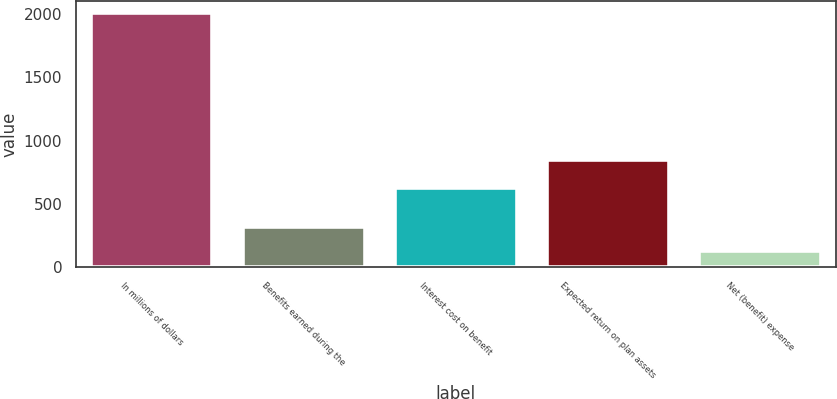Convert chart to OTSL. <chart><loc_0><loc_0><loc_500><loc_500><bar_chart><fcel>In millions of dollars<fcel>Benefits earned during the<fcel>Interest cost on benefit<fcel>Expected return on plan assets<fcel>Net (benefit) expense<nl><fcel>2006<fcel>318.5<fcel>630<fcel>845<fcel>131<nl></chart> 